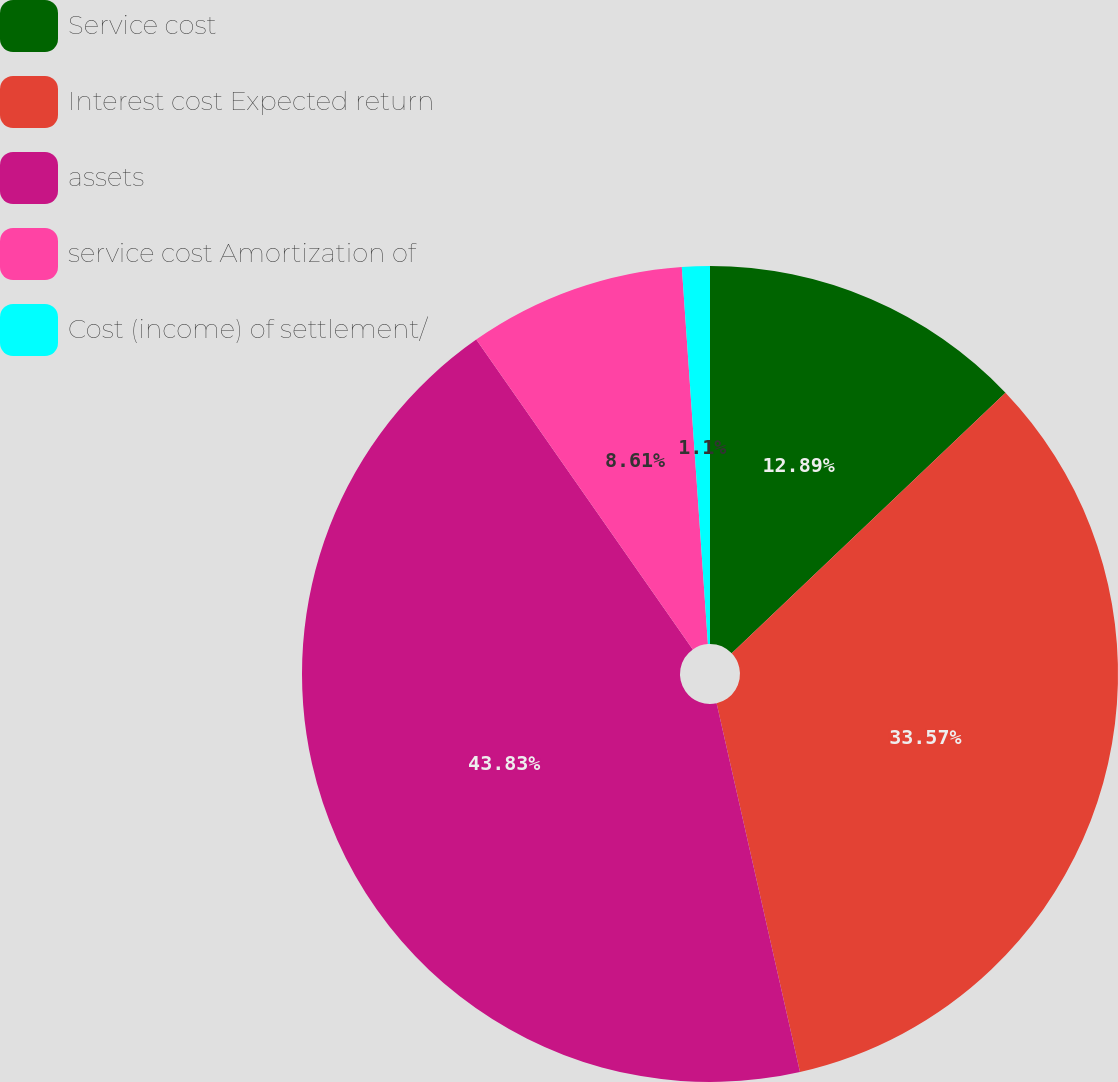<chart> <loc_0><loc_0><loc_500><loc_500><pie_chart><fcel>Service cost<fcel>Interest cost Expected return<fcel>assets<fcel>service cost Amortization of<fcel>Cost (income) of settlement/<nl><fcel>12.89%<fcel>33.57%<fcel>43.83%<fcel>8.61%<fcel>1.1%<nl></chart> 